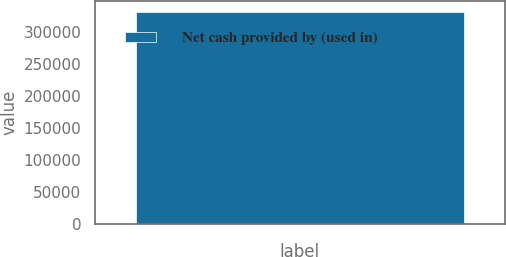Convert chart. <chart><loc_0><loc_0><loc_500><loc_500><bar_chart><fcel>Net cash provided by (used in)<nl><fcel>332328<nl></chart> 